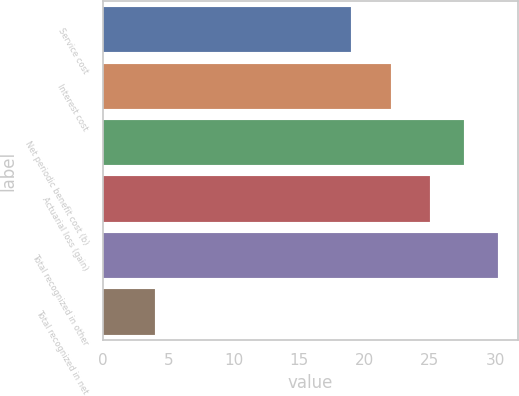Convert chart to OTSL. <chart><loc_0><loc_0><loc_500><loc_500><bar_chart><fcel>Service cost<fcel>Interest cost<fcel>Net periodic benefit cost (b)<fcel>Actuarial loss (gain)<fcel>Total recognized in other<fcel>Total recognized in net<nl><fcel>19<fcel>22<fcel>27.6<fcel>25<fcel>30.2<fcel>4<nl></chart> 